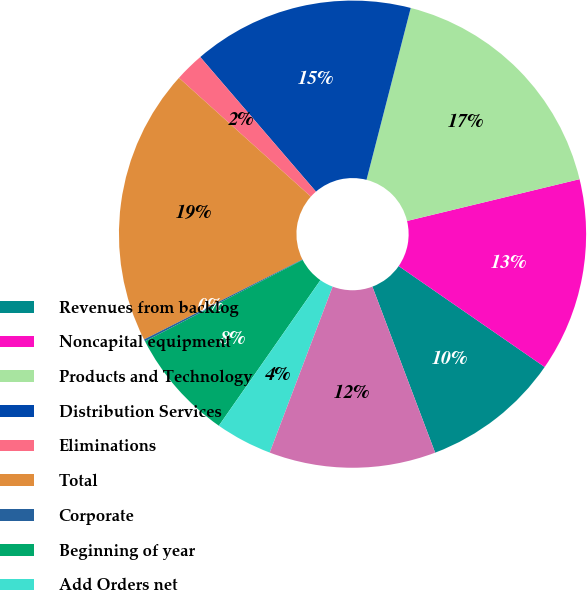Convert chart. <chart><loc_0><loc_0><loc_500><loc_500><pie_chart><fcel>Revenues from backlog<fcel>Noncapital equipment<fcel>Products and Technology<fcel>Distribution Services<fcel>Eliminations<fcel>Total<fcel>Corporate<fcel>Beginning of year<fcel>Add Orders net<fcel>Less Revenues<nl><fcel>9.62%<fcel>13.41%<fcel>17.21%<fcel>15.31%<fcel>2.03%<fcel>19.11%<fcel>0.14%<fcel>7.72%<fcel>3.93%<fcel>11.52%<nl></chart> 